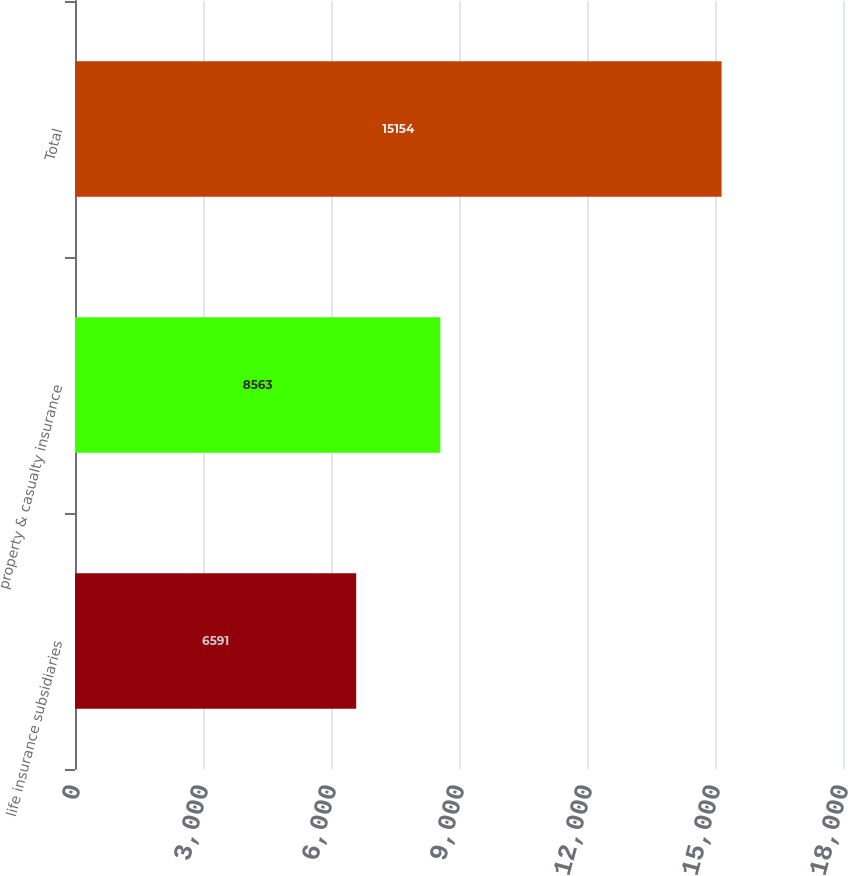Convert chart. <chart><loc_0><loc_0><loc_500><loc_500><bar_chart><fcel>life insurance subsidiaries<fcel>property & casualty insurance<fcel>Total<nl><fcel>6591<fcel>8563<fcel>15154<nl></chart> 